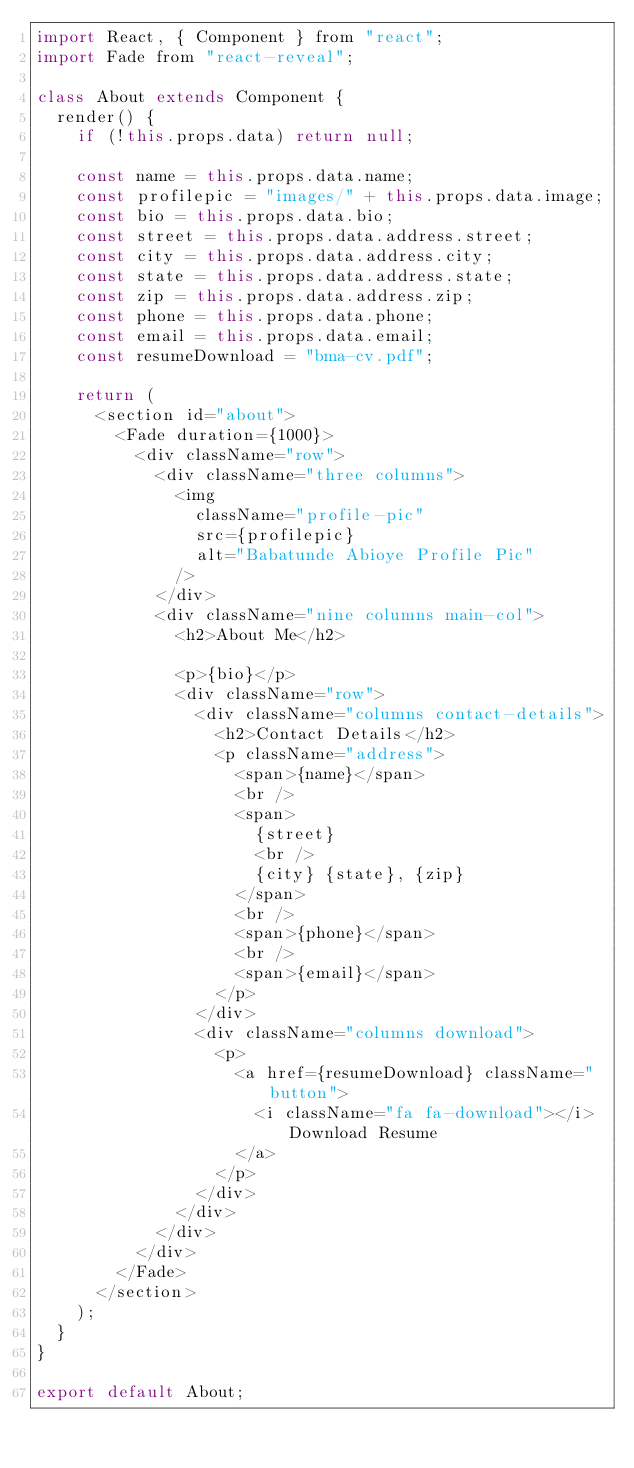Convert code to text. <code><loc_0><loc_0><loc_500><loc_500><_JavaScript_>import React, { Component } from "react";
import Fade from "react-reveal";

class About extends Component {
  render() {
    if (!this.props.data) return null;

    const name = this.props.data.name;
    const profilepic = "images/" + this.props.data.image;
    const bio = this.props.data.bio;
    const street = this.props.data.address.street;
    const city = this.props.data.address.city;
    const state = this.props.data.address.state;
    const zip = this.props.data.address.zip;
    const phone = this.props.data.phone;
    const email = this.props.data.email;
    const resumeDownload = "bma-cv.pdf";

    return (
      <section id="about">
        <Fade duration={1000}>
          <div className="row">
            <div className="three columns">
              <img
                className="profile-pic"
                src={profilepic}
                alt="Babatunde Abioye Profile Pic"
              />
            </div>
            <div className="nine columns main-col">
              <h2>About Me</h2>

              <p>{bio}</p>
              <div className="row">
                <div className="columns contact-details">
                  <h2>Contact Details</h2>
                  <p className="address">
                    <span>{name}</span>
                    <br />
                    <span>
                      {street}
                      <br />
                      {city} {state}, {zip}
                    </span>
                    <br />
                    <span>{phone}</span>
                    <br />
                    <span>{email}</span>
                  </p>
                </div>
                <div className="columns download">
                  <p>
                    <a href={resumeDownload} className="button">
                      <i className="fa fa-download"></i>Download Resume
                    </a>
                  </p>
                </div>
              </div>
            </div>
          </div>
        </Fade>
      </section>
    );
  }
}

export default About;
</code> 